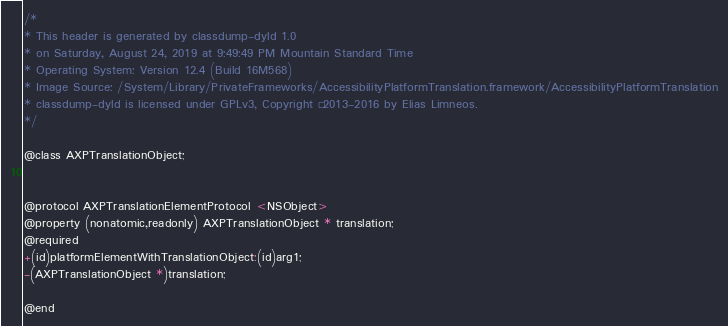<code> <loc_0><loc_0><loc_500><loc_500><_C_>/*
* This header is generated by classdump-dyld 1.0
* on Saturday, August 24, 2019 at 9:49:49 PM Mountain Standard Time
* Operating System: Version 12.4 (Build 16M568)
* Image Source: /System/Library/PrivateFrameworks/AccessibilityPlatformTranslation.framework/AccessibilityPlatformTranslation
* classdump-dyld is licensed under GPLv3, Copyright © 2013-2016 by Elias Limneos.
*/

@class AXPTranslationObject;


@protocol AXPTranslationElementProtocol <NSObject>
@property (nonatomic,readonly) AXPTranslationObject * translation; 
@required
+(id)platformElementWithTranslationObject:(id)arg1;
-(AXPTranslationObject *)translation;

@end

</code> 